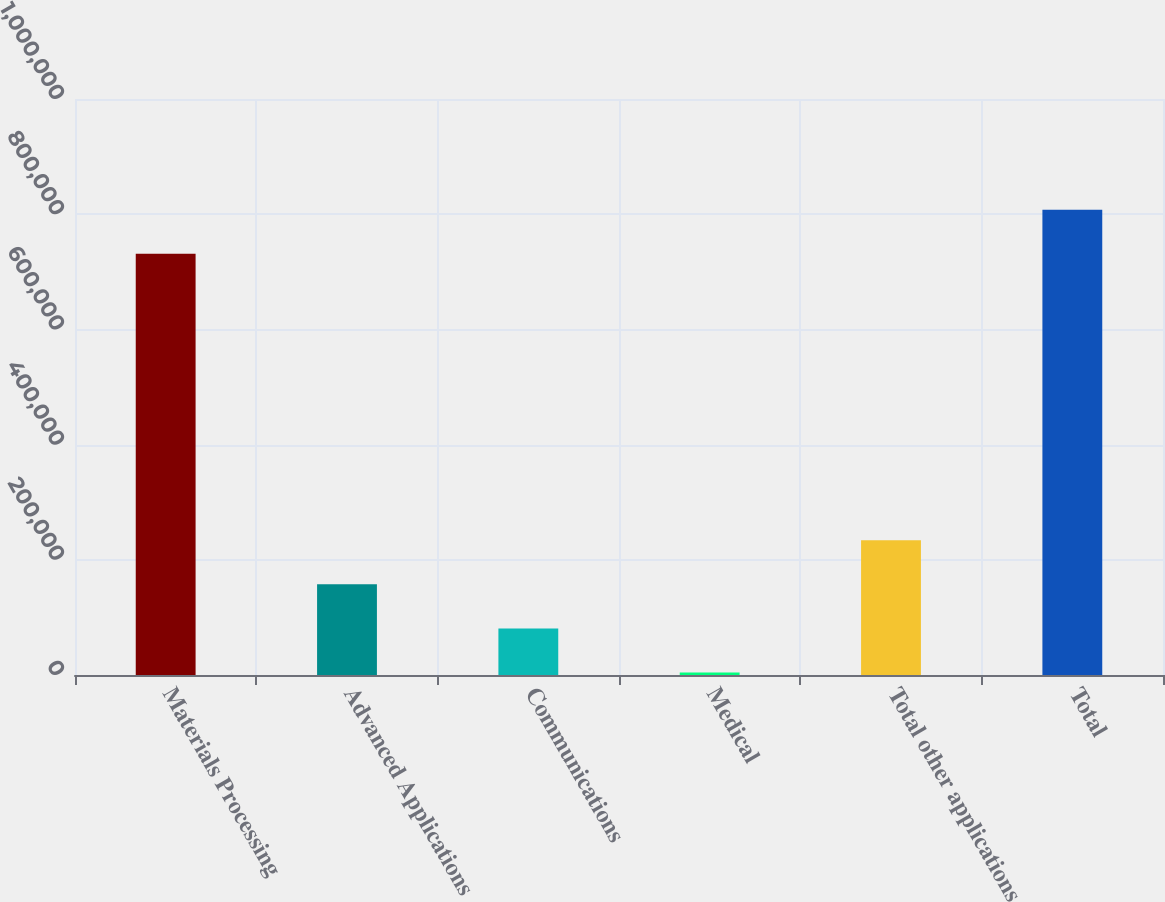Convert chart. <chart><loc_0><loc_0><loc_500><loc_500><bar_chart><fcel>Materials Processing<fcel>Advanced Applications<fcel>Communications<fcel>Medical<fcel>Total other applications<fcel>Total<nl><fcel>731274<fcel>157431<fcel>80881.1<fcel>4331<fcel>233981<fcel>807824<nl></chart> 